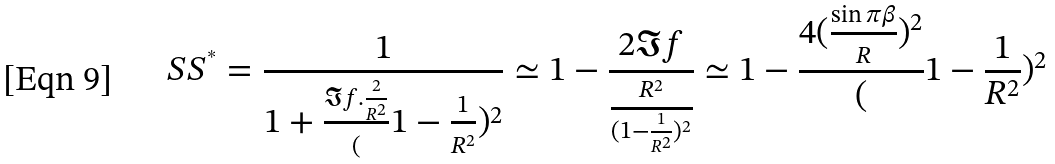<formula> <loc_0><loc_0><loc_500><loc_500>S S ^ { ^ { * } } = \frac { 1 } { 1 + \frac { \Im f . \frac { 2 } { R ^ { 2 } } } ( 1 - \frac { 1 } { R ^ { 2 } } ) ^ { 2 } } \simeq 1 - \frac { 2 \Im f } { \frac { R ^ { 2 } } { ( 1 - \frac { 1 } { R ^ { 2 } } ) ^ { 2 } } } \simeq 1 - \frac { 4 ( \frac { \sin \pi \beta } { R } ) ^ { 2 } } ( 1 - \frac { 1 } { R ^ { 2 } } ) ^ { 2 }</formula> 